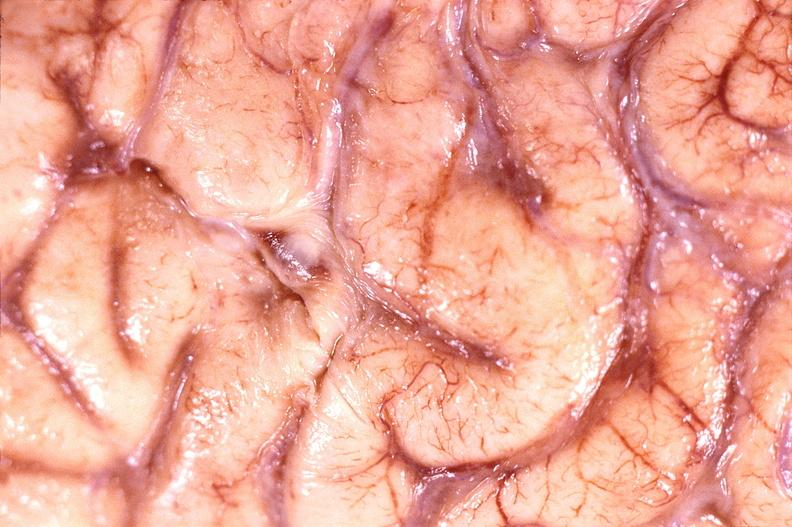what is present?
Answer the question using a single word or phrase. Nervous 